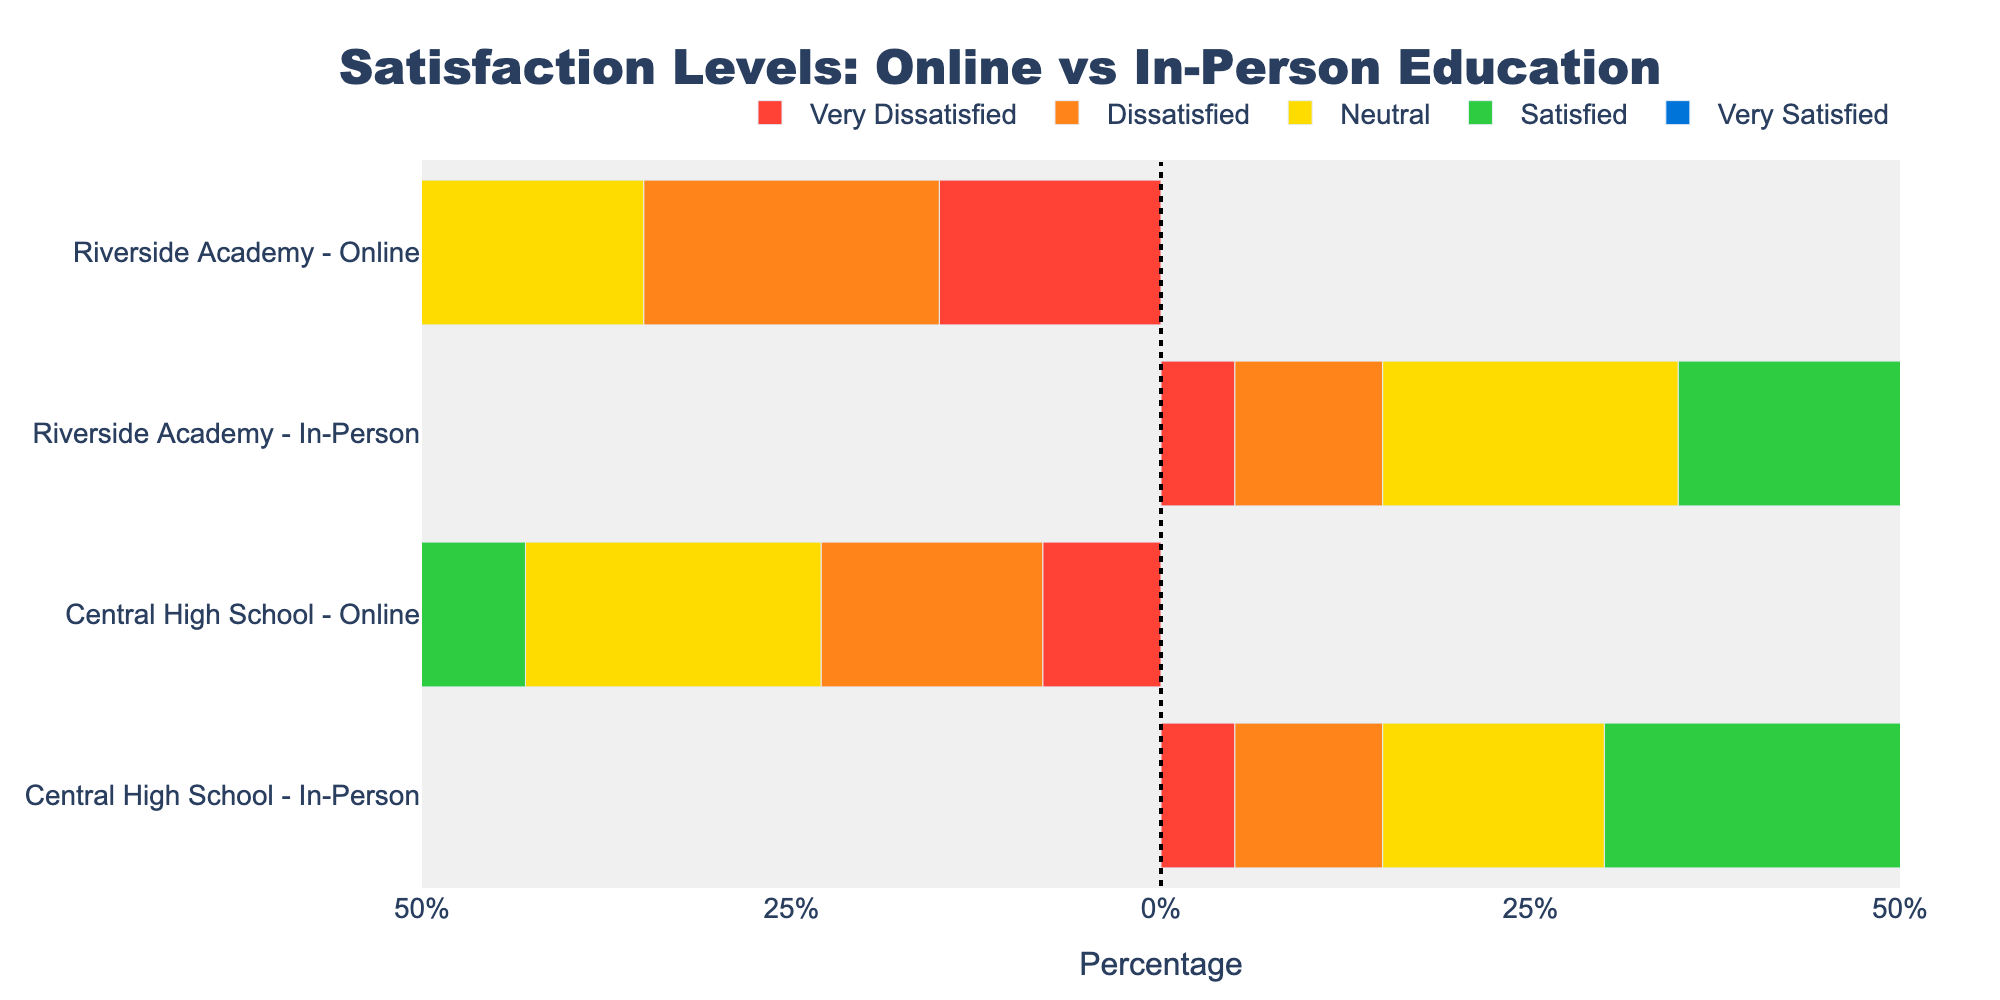Which method has a higher percentage of "Very Satisfied" students at Central High School? For Central High School, the "Very Satisfied" percentages are 12% for online and 40% for in-person. Since 40% is greater than 12%, in-person has a higher percentage.
Answer: In-person Which method at Riverside Academy has the higher percentage of "Dissatisfied" students? At Riverside Academy, the "Dissatisfied" percentages are 20% for online and 10% for in-person. Since 20% is greater than 10%, online has the higher percentage.
Answer: Online How much higher is the "Satisfied" percentage for in-person than online at Central High School? At Central High School, the "Satisfied" percentages are 25% for online and 30% for in-person. The difference is 30% - 25% = 5%.
Answer: 5% What is the combined percentage of "Very Dissatisfied" students across both methods at Riverside Academy? At Riverside Academy, the "Very Dissatisfied" percentages are 15% for online and 5% for in-person. Therefore, the combined percentage is 15% + 5% = 20%.
Answer: 20% For Central High School, what is the difference in the percentage of "Neutral" students between online and in-person methods? The "Neutral" percentages at Central High School are 20% for online and 15% for in-person. The difference is 20% - 15% = 5%.
Answer: 5% Compare the highest satisfaction levels ("Very Satisfied") between Central High School and Riverside Academy for in-person education. Which school has a higher percentage? The "Very Satisfied" percentages for in-person education are 40% at Central High School and 35% at Riverside Academy. Since 40% is greater than 35%, Central High School has a higher percentage.
Answer: Central High School What percentage of students at Central High School are either "Dissatisfied" or "Very Dissatisfied" with online education? For online education at Central High School, the combined percentage of "Dissatisfied" and "Very Dissatisfied" is 15% + 8% = 23%.
Answer: 23% How does the "Satisfied" percentage for online education at Riverside Academy compare to the "Neutral" percentage for in-person education at the same school? At Riverside Academy, the "Satisfied" percentage for online education is 30%, and the "Neutral" percentage for in-person education is 20%. Since 30% is greater than 20%, the "Satisfied" percentage for online is higher.
Answer: Online, 30% is higher 